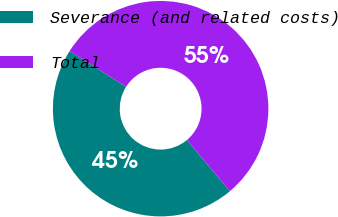Convert chart to OTSL. <chart><loc_0><loc_0><loc_500><loc_500><pie_chart><fcel>Severance (and related costs)<fcel>Total<nl><fcel>45.09%<fcel>54.91%<nl></chart> 